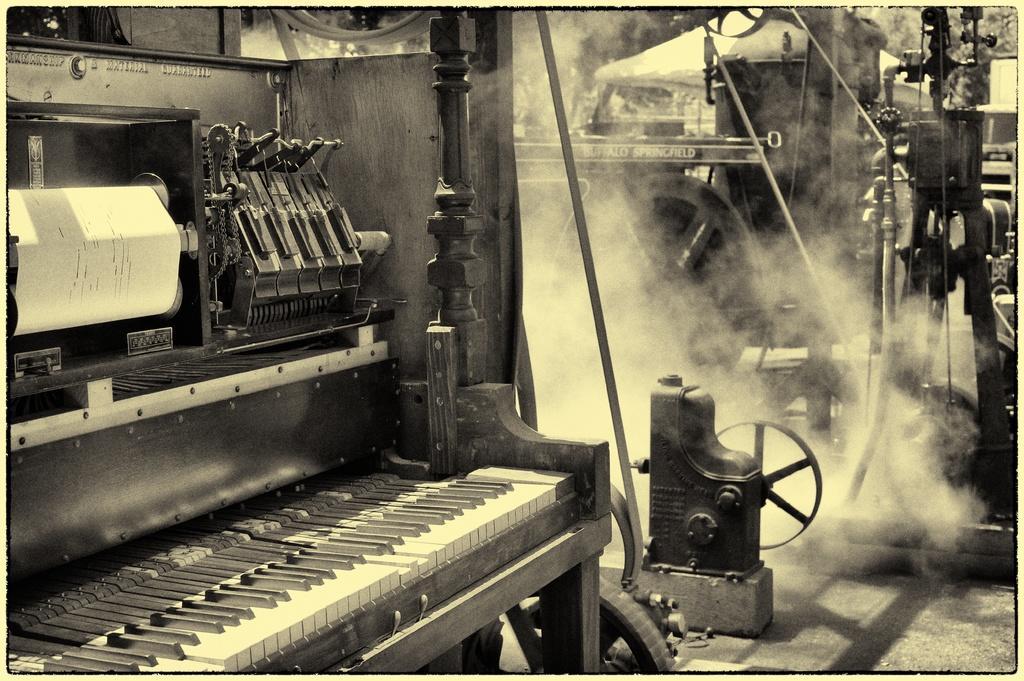Could you give a brief overview of what you see in this image? This is a piano. In this there are paper. And in the background there are smoke and some other equipment. 